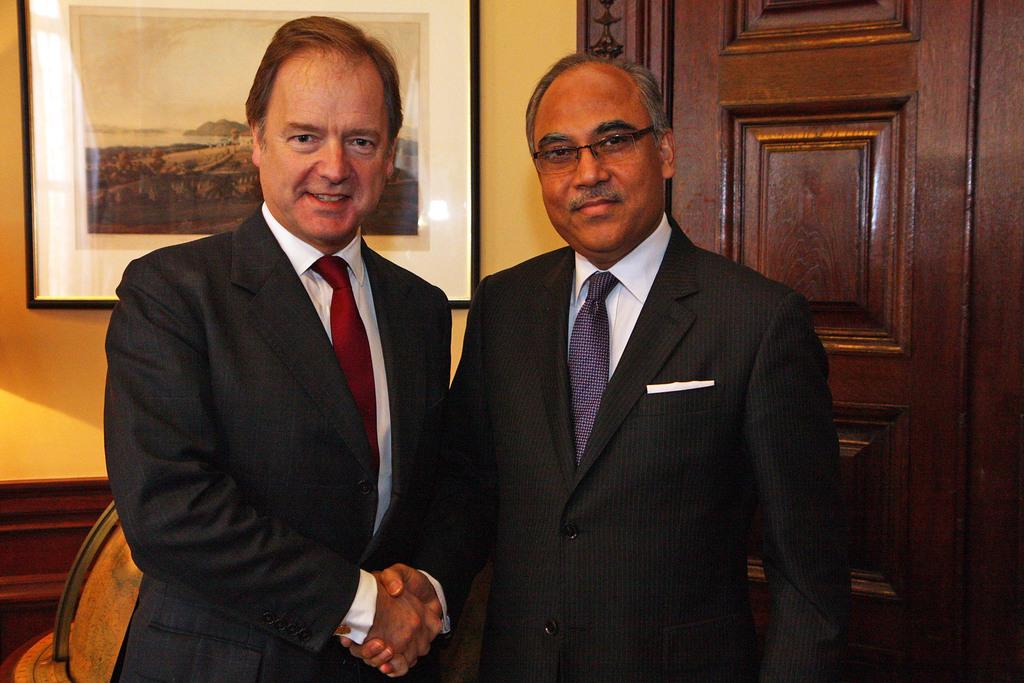How many people are in the image? There are two persons in the image. What are the persons wearing? Both persons are wearing blazers and ties. Where is the door located in the image? The door is on the right side of the image. What is present at the top of the image? There is a photo frame at the top of the image. What color is the copper toe visible in the image? There is no copper toe present in the image. How are the scissors being used in the image? There are no scissors present in the image. 